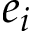Convert formula to latex. <formula><loc_0><loc_0><loc_500><loc_500>e _ { i }</formula> 